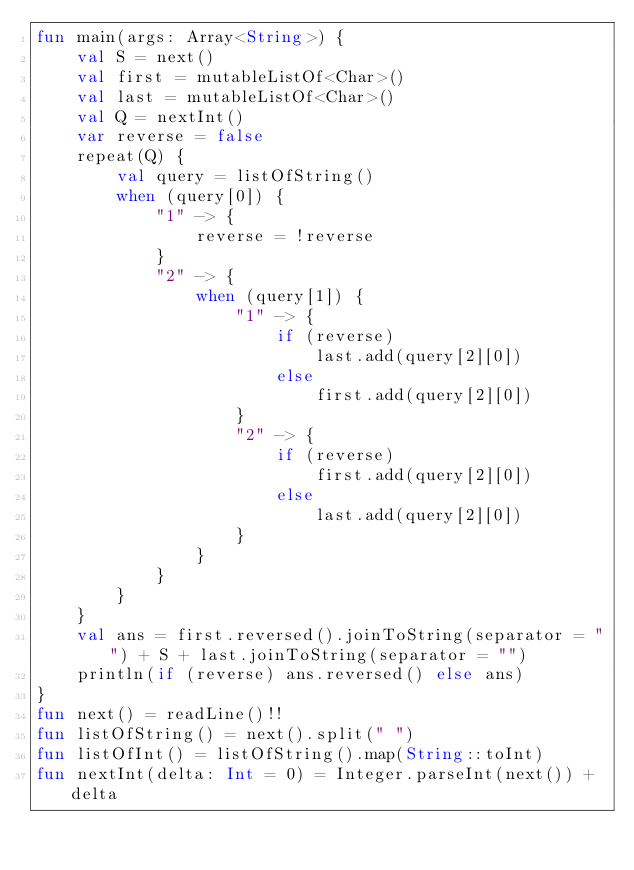Convert code to text. <code><loc_0><loc_0><loc_500><loc_500><_Kotlin_>fun main(args: Array<String>) {
    val S = next()
    val first = mutableListOf<Char>()
    val last = mutableListOf<Char>()
    val Q = nextInt()
    var reverse = false
    repeat(Q) {
        val query = listOfString()
        when (query[0]) {
            "1" -> {
                reverse = !reverse
            }
            "2" -> {
                when (query[1]) {
                    "1" -> {
                        if (reverse)
                            last.add(query[2][0])
                        else
                            first.add(query[2][0])
                    }
                    "2" -> {
                        if (reverse)
                            first.add(query[2][0])
                        else
                            last.add(query[2][0])
                    }
                }
            }
        }
    }
    val ans = first.reversed().joinToString(separator = "") + S + last.joinToString(separator = "")
    println(if (reverse) ans.reversed() else ans)
}
fun next() = readLine()!!
fun listOfString() = next().split(" ")
fun listOfInt() = listOfString().map(String::toInt)
fun nextInt(delta: Int = 0) = Integer.parseInt(next()) + delta
</code> 